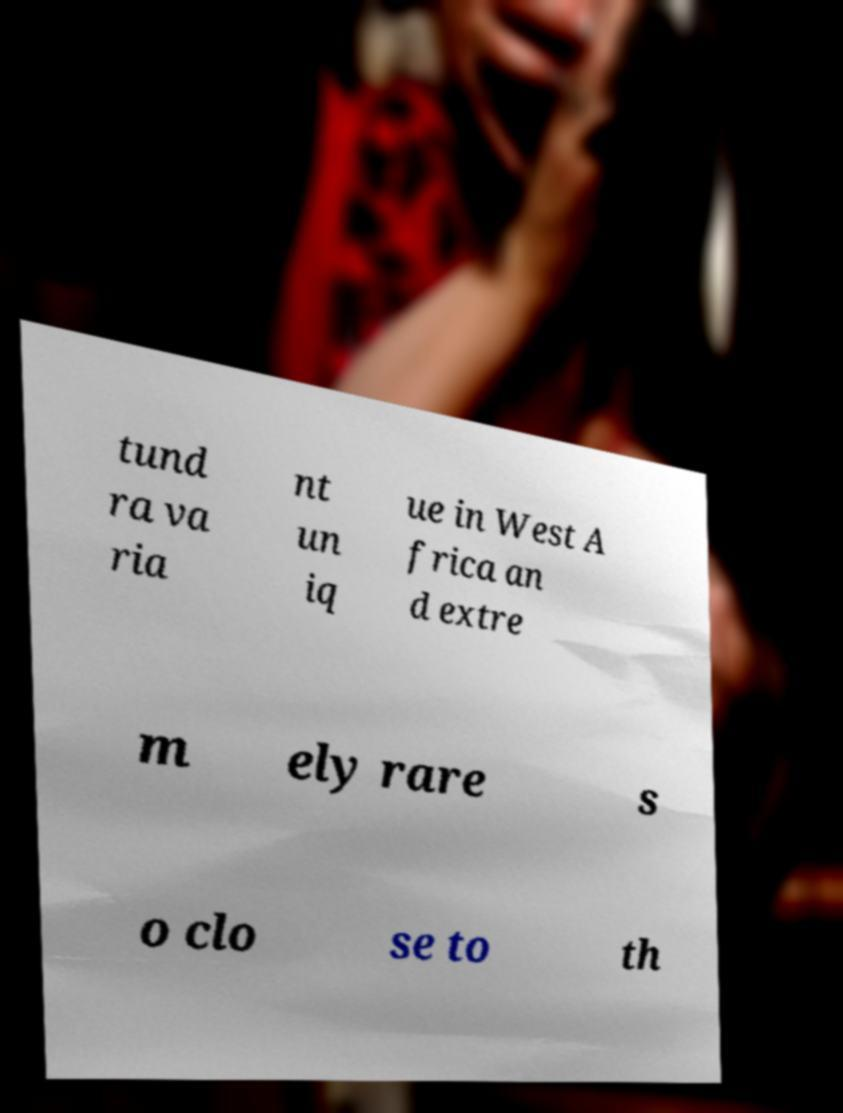For documentation purposes, I need the text within this image transcribed. Could you provide that? tund ra va ria nt un iq ue in West A frica an d extre m ely rare s o clo se to th 